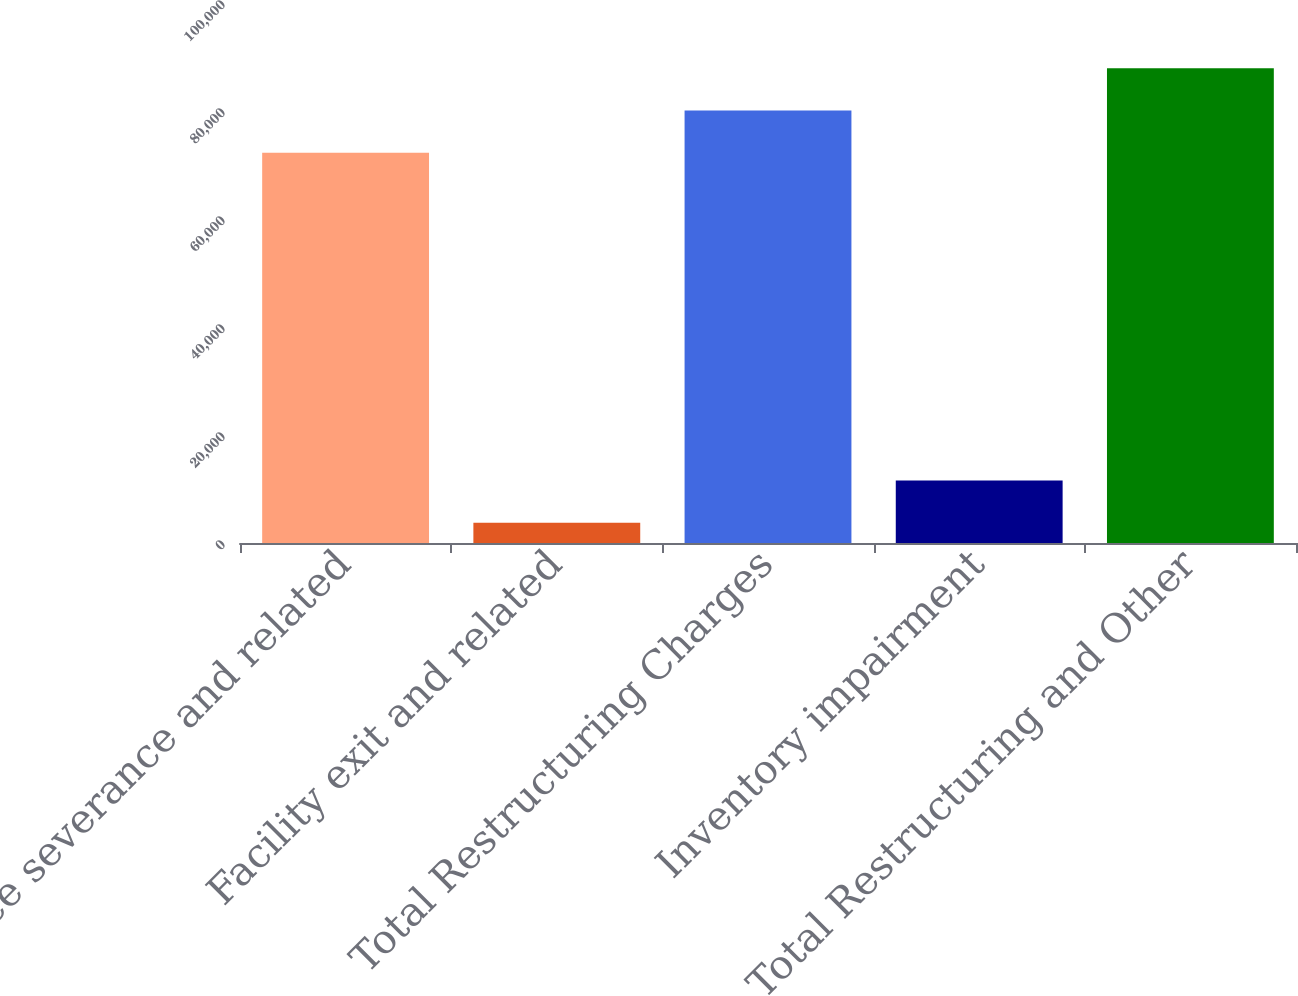Convert chart to OTSL. <chart><loc_0><loc_0><loc_500><loc_500><bar_chart><fcel>Employee severance and related<fcel>Facility exit and related<fcel>Total Restructuring Charges<fcel>Inventory impairment<fcel>Total Restructuring and Other<nl><fcel>72257<fcel>3753<fcel>80078.2<fcel>11574.2<fcel>87899.4<nl></chart> 